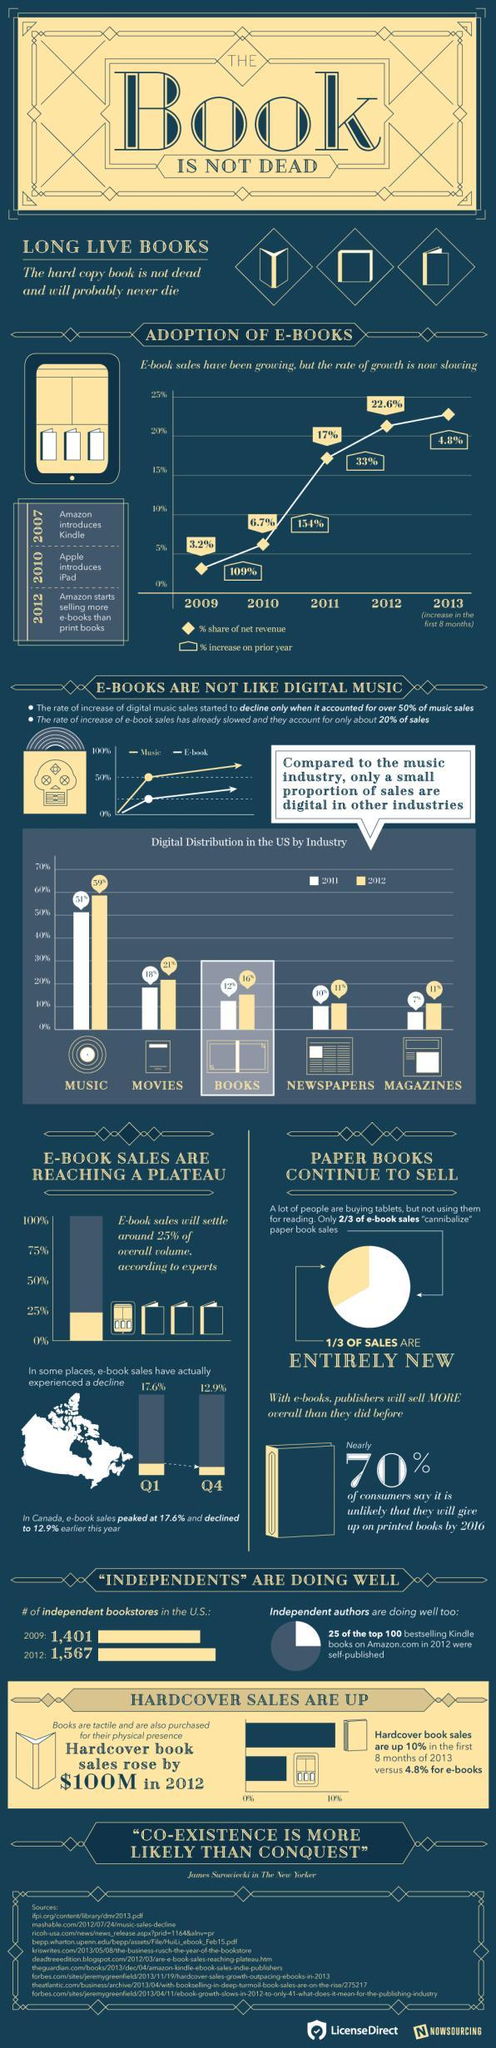What is the percentage share of net revenue in e-book sales in 2011?
Answer the question with a short phrase. 17% Which industry has showed the second-highest percent of digital distribution in the U.S. in 2011? MOVIES What percentage is the digital distribution in the newspaper industry in the U.S. in 2012? 11% What percentage is the digital distribution in the music industry in the U.S. in 2012? 59% What is the percentage share of net revenue in e-book sales in 2009? 3.2% When did amazon launched Kindle? 2007 Which industry has showed the least percent of digital distribution in the U.S. in 2011? MAGAZINES When did Amazon start selling more e-books than printed books? 2012 